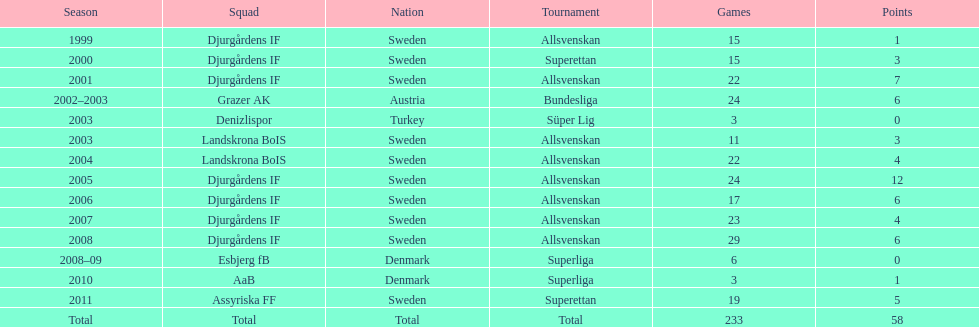How many teams had above 20 matches in the season? 6. 